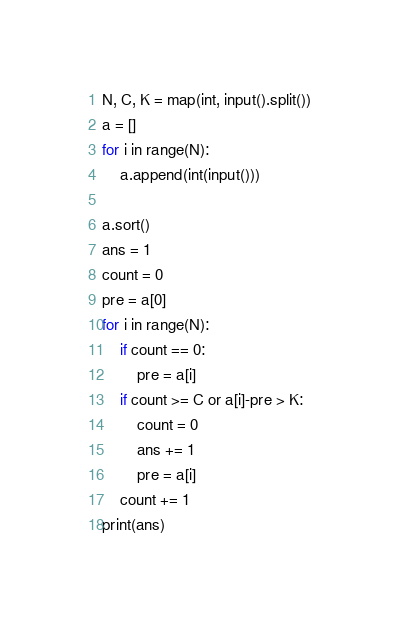Convert code to text. <code><loc_0><loc_0><loc_500><loc_500><_Python_>N, C, K = map(int, input().split())
a = []
for i in range(N):
    a.append(int(input()))

a.sort()
ans = 1
count = 0
pre = a[0]
for i in range(N):
    if count == 0:
        pre = a[i]
    if count >= C or a[i]-pre > K:
        count = 0
        ans += 1
        pre = a[i]
    count += 1
print(ans)
</code> 